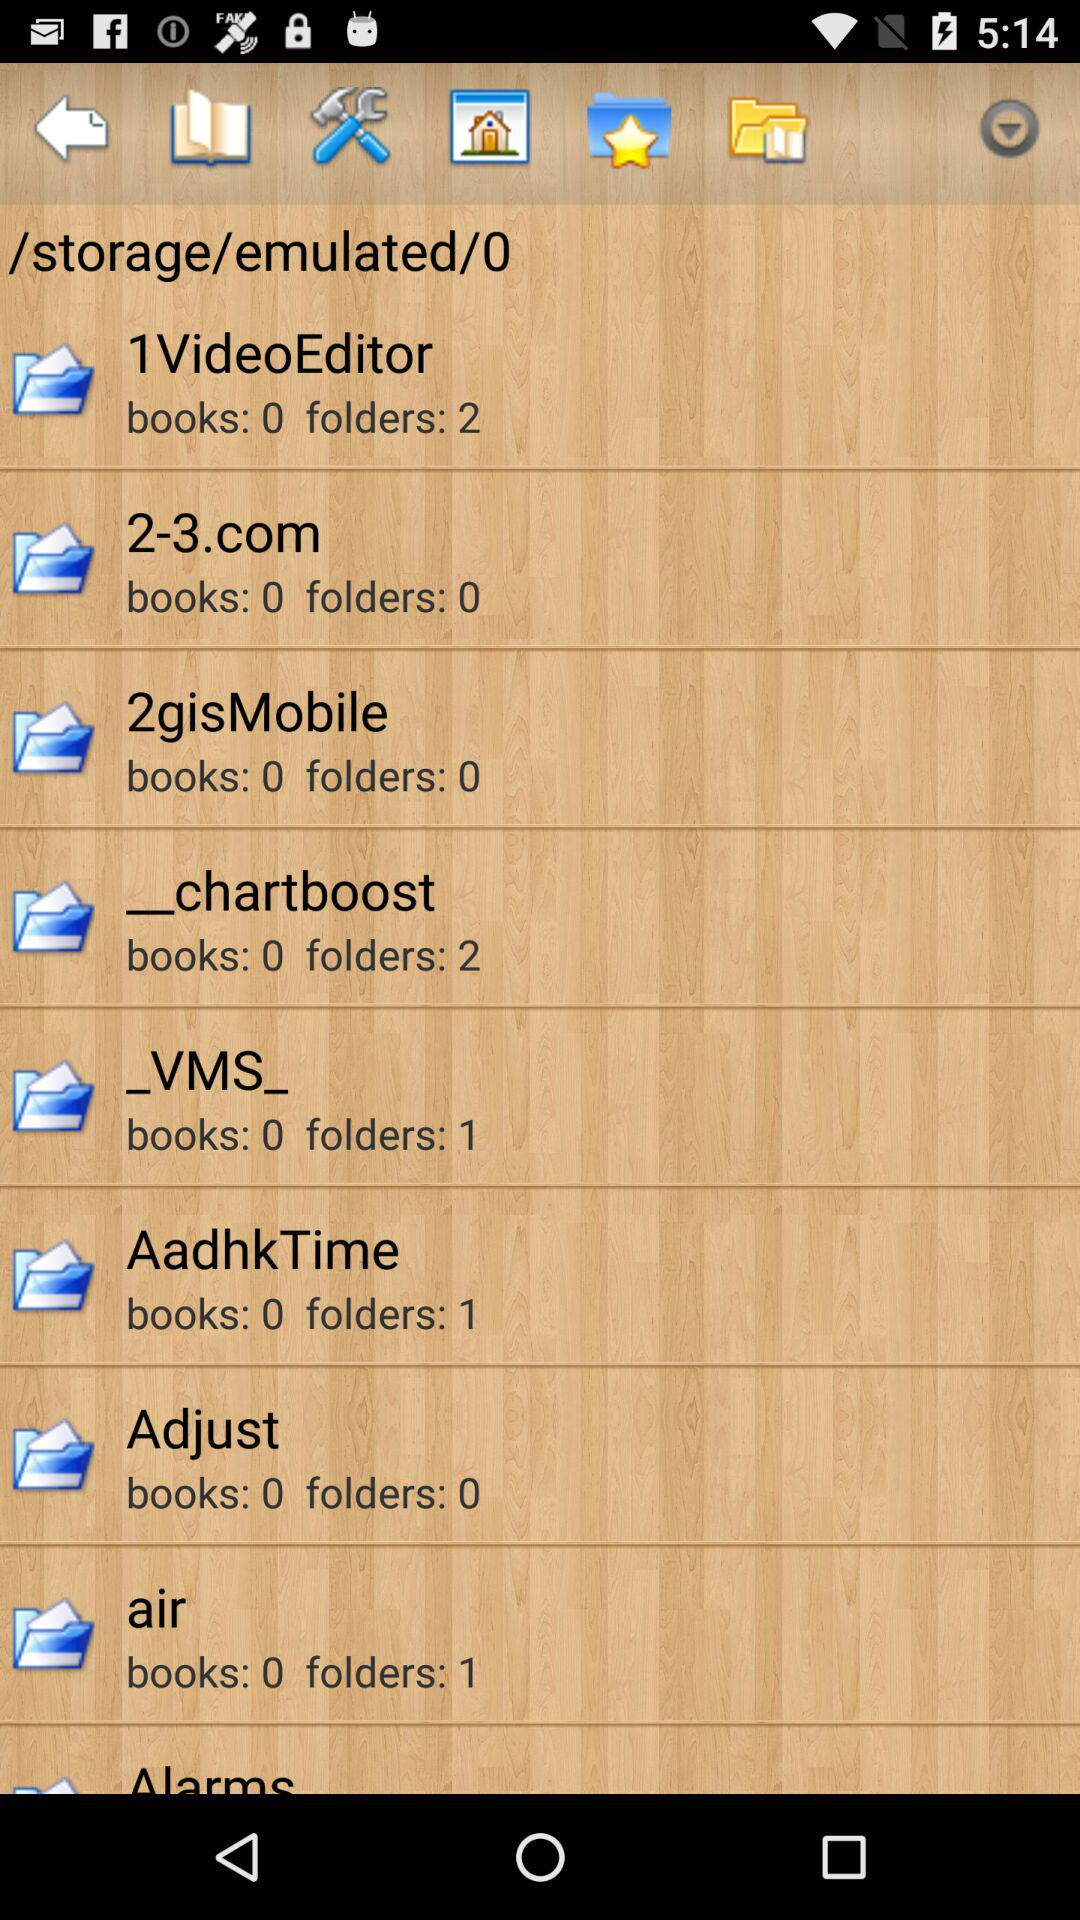How many folders does "air" have? There is 1 folder in "air". 